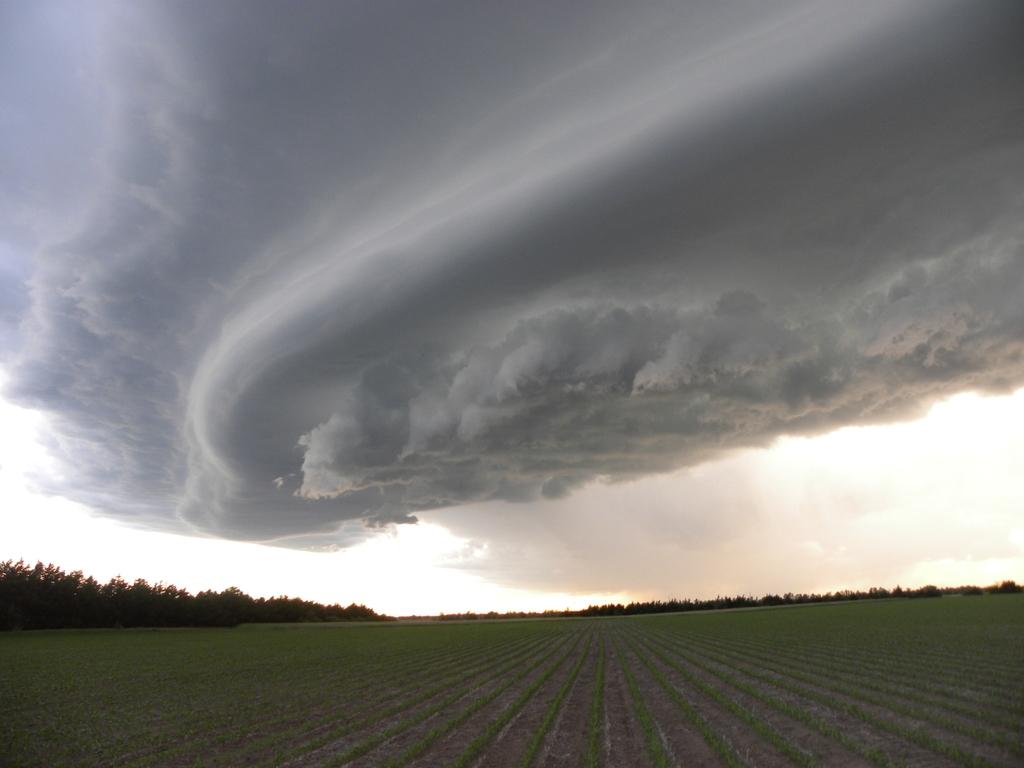What is the setting of the image? The image is an outside view. What can be seen in the sky in the image? There are clouds in the sky. What type of landscape is visible at the bottom of the image? There is a field at the bottom of the image. Where is the fireman located in the image? There is no fireman present in the image. What type of stitch is used to create the clouds in the image? The clouds in the image are natural formations and do not involve any stitching. 